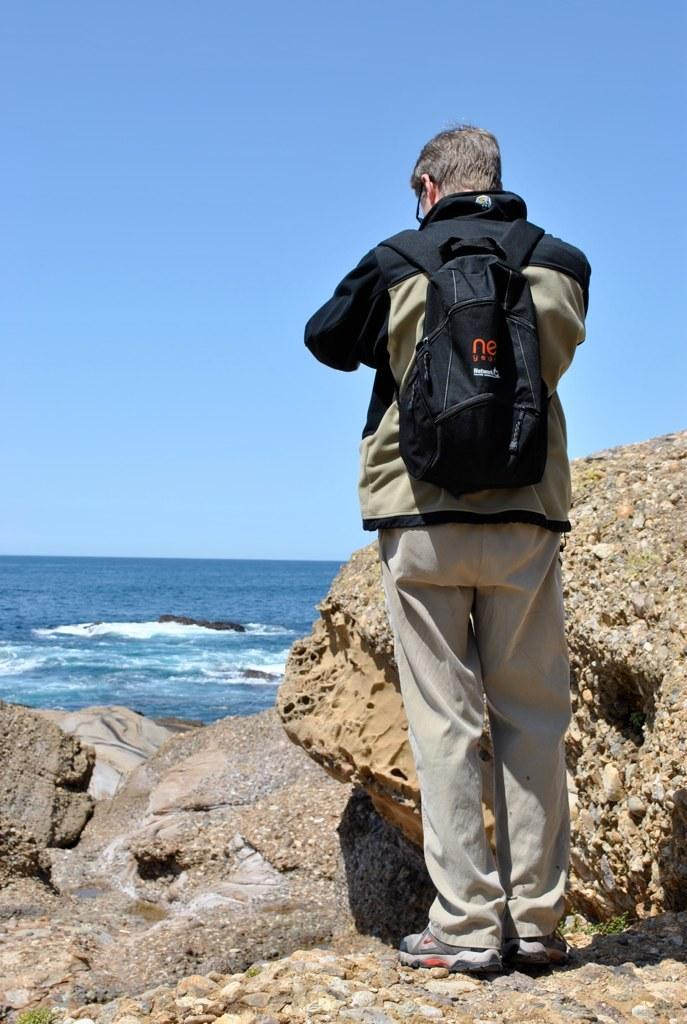What is the main subject of the image? The main subject of the image is a man standing. What is the man wearing in the image? The man is wearing a backpack. What natural feature can be seen in the background of the image? There is an ocean visible in the image. What type of wave can be seen crashing onto the shore in the image? There is no wave crashing onto the shore in the image; it only shows a man standing and an ocean in the background. How does the man sneeze in the image? The image does not depict the man sneezing; he is simply standing. 